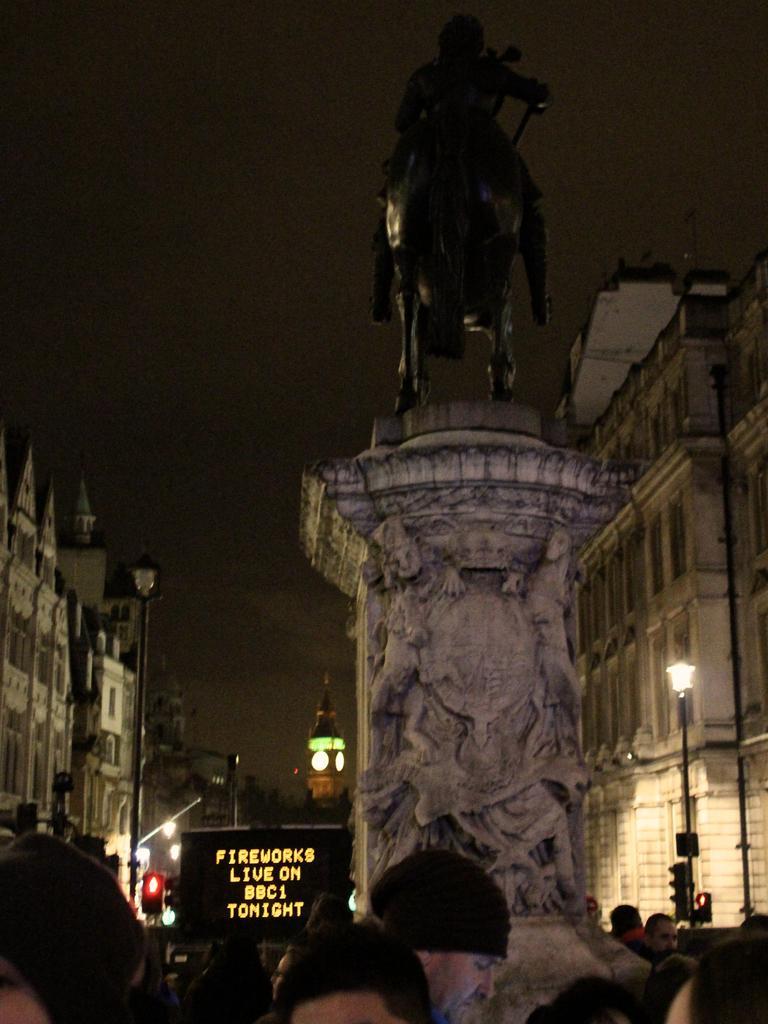Please provide a concise description of this image. In this image I can see few people in the front and in the centre of this image I can see a sculpture. In the background I can see number of poles, number of lights, few buildings, a board on the bottom side and on it I can see something is written. 